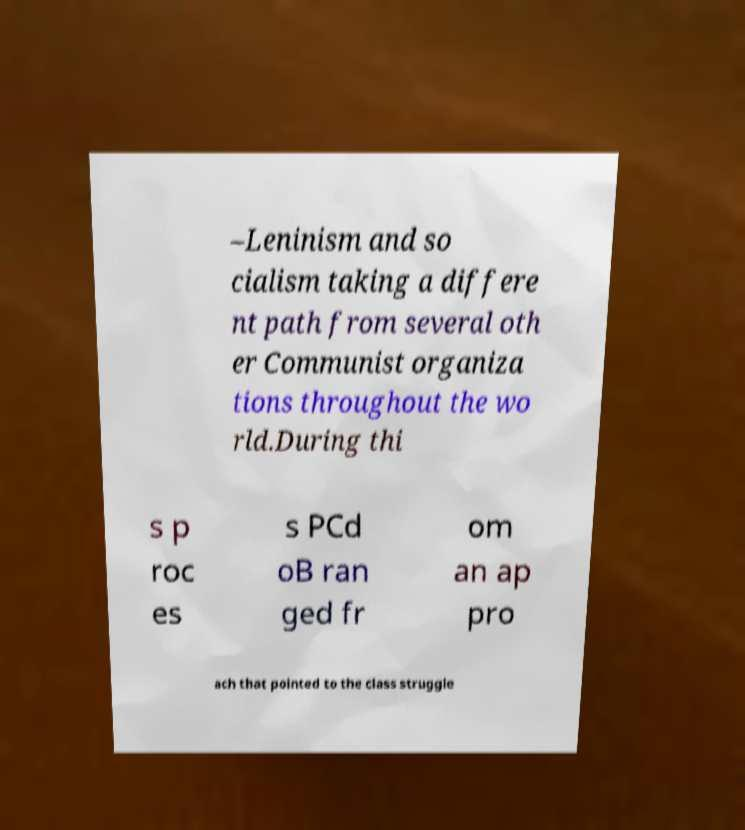Could you extract and type out the text from this image? –Leninism and so cialism taking a differe nt path from several oth er Communist organiza tions throughout the wo rld.During thi s p roc es s PCd oB ran ged fr om an ap pro ach that pointed to the class struggle 